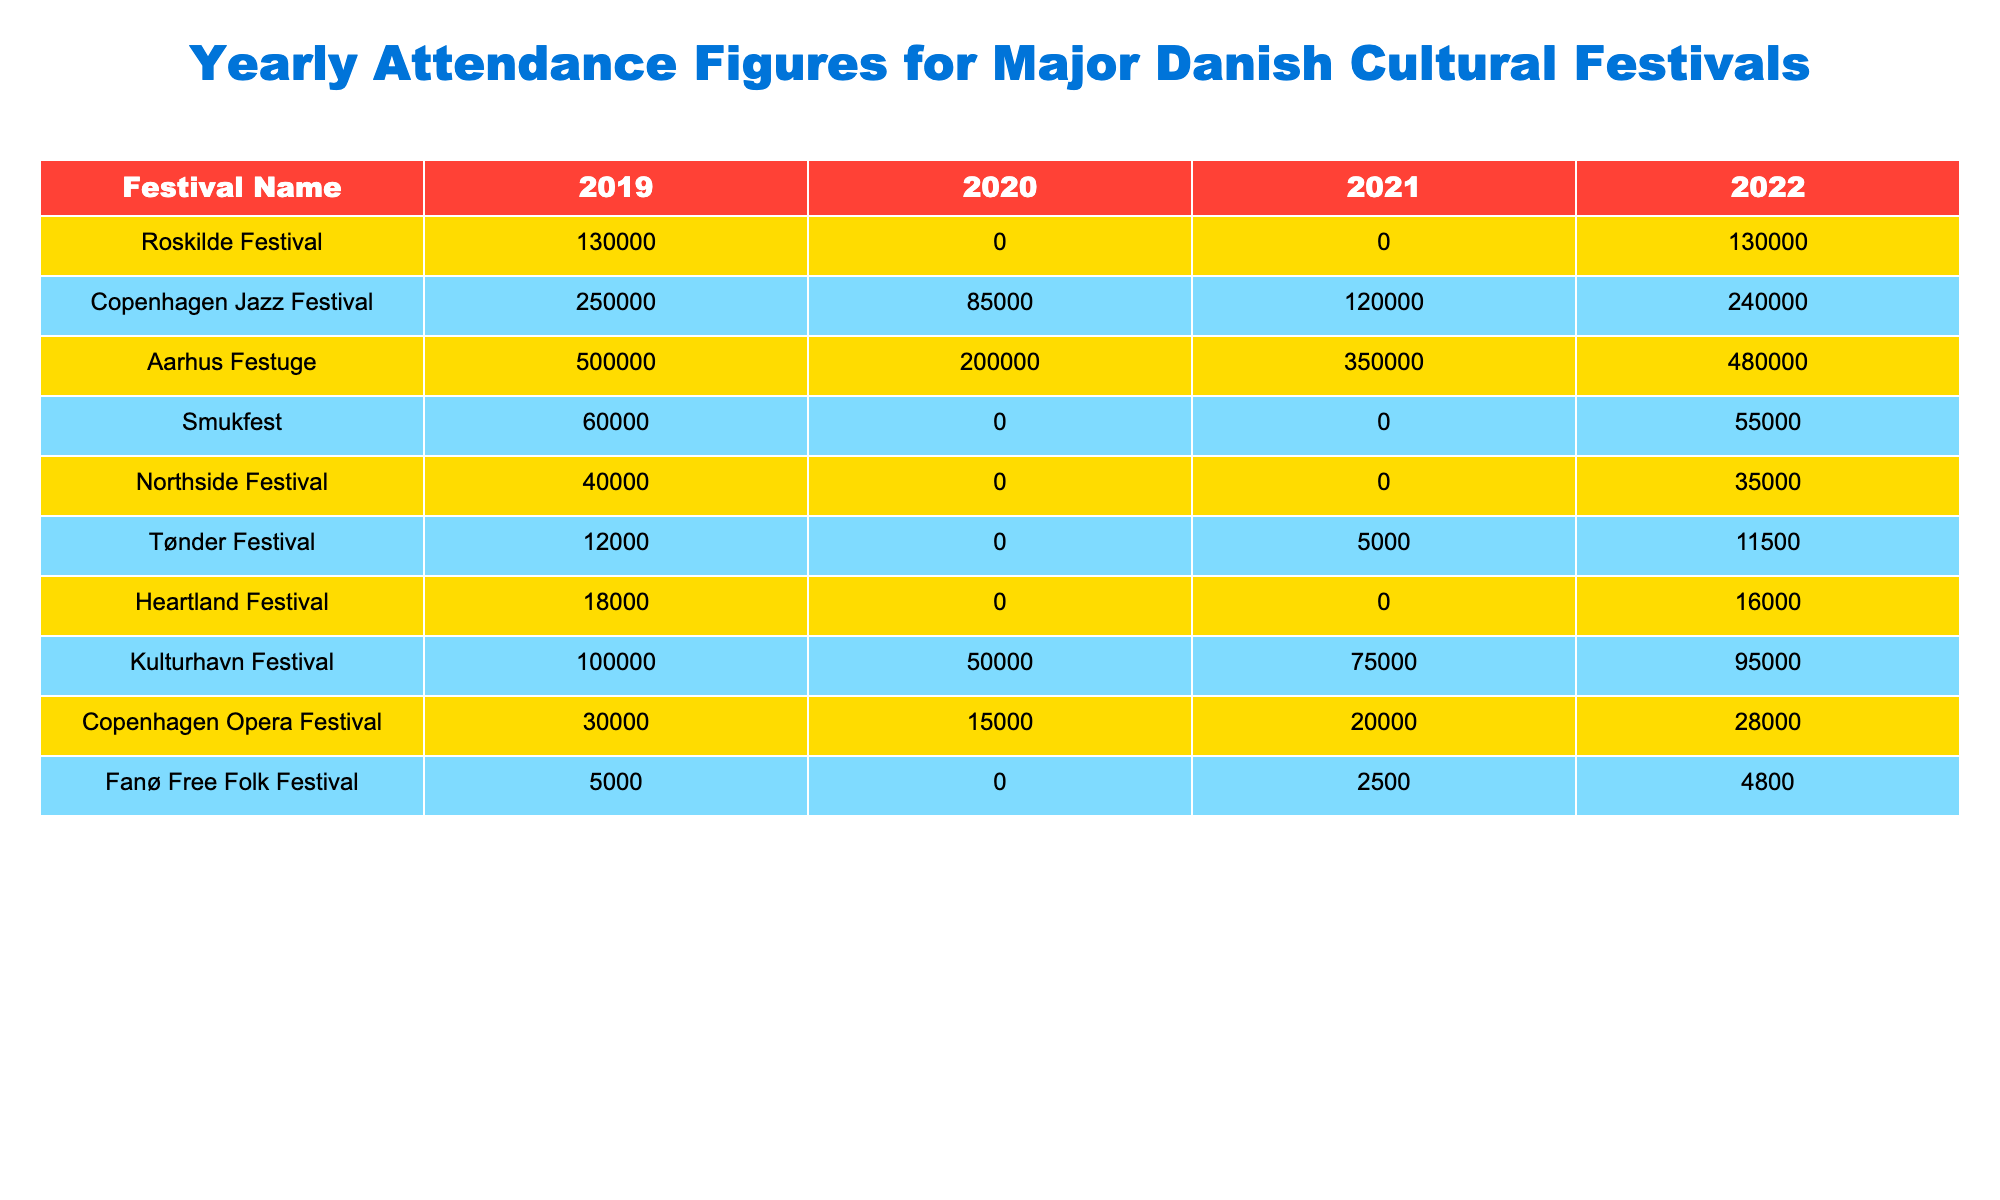What was the attendance for the Copenhagen Jazz Festival in 2021? The table shows that the attendance for the Copenhagen Jazz Festival in 2021 is 120,000.
Answer: 120,000 Which festival had the highest attendance in 2019? By checking the attendance figures for 2019, Aarhus Festuge had the highest attendance with 500,000.
Answer: Aarhus Festuge Did the Northside Festival have any attendees in 2020? The attendance figure for the Northside Festival in 2020 is 0, indicating that there were no attendees that year.
Answer: Yes What was the total attendance for the Tønder Festival from 2019 to 2022? Adding the attendance figures from the provided years: 12,000 (2019) + 0 (2020) + 5,000 (2021) + 11,500 (2022) equals 28,500.
Answer: 28,500 Which festival saw a decrease in attendance from 2019 to 2020? The table indicates that both Roskilde Festival and Smukfest saw reductions; Roskilde's attendance dropped from 130,000 to 0, while Smukfest dropped from 60,000 to 0.
Answer: Roskilde Festival and Smukfest How many festivals had attendance figures of 0 in 2020? The table shows that there are four festivals (Roskilde Festival, Smukfest, Northside Festival, and Tønder Festival) with 0 attendance in 2020.
Answer: 4 What is the average attendance for Aarhus Festuge over the years displayed in the table? Adding the attendance figures for Aarhus Festuge: 500,000 + 200,000 + 350,000 + 480,000 equals 1,530,000, and dividing by 4 gives an average of 382,500.
Answer: 382,500 Which festival had the most significant increase in attendance from 2020 to 2022? The attendance figures show Aarhus Festuge increased from 200,000 in 2020 to 480,000 in 2022, a change of 280,000, making it the largest increase.
Answer: Aarhus Festuge Was the total attendance for Copenhagen Jazz Festival higher or lower in 2022 compared to 2019? The attendance for Copenhagen Jazz Festival was 250,000 in 2019 and 240,000 in 2022, showing it was lower in 2022.
Answer: Lower What was the total attendance for the festivals listed in 2021? Adding the attendance figures for all festivals in 2021: 0 (Roskilde) + 120,000 (Copenhagen Jazz) + 350,000 (Aarhus) + 0 (Smukfest) + 0 (Northside) + 5,000 (Tønder) + 0 (Heartland) + 75,000 (Kulturhavn) + 20,000 (Copenhagen Opera) + 2,500 (Fanø Free Folk) equals 572,500.
Answer: 572,500 